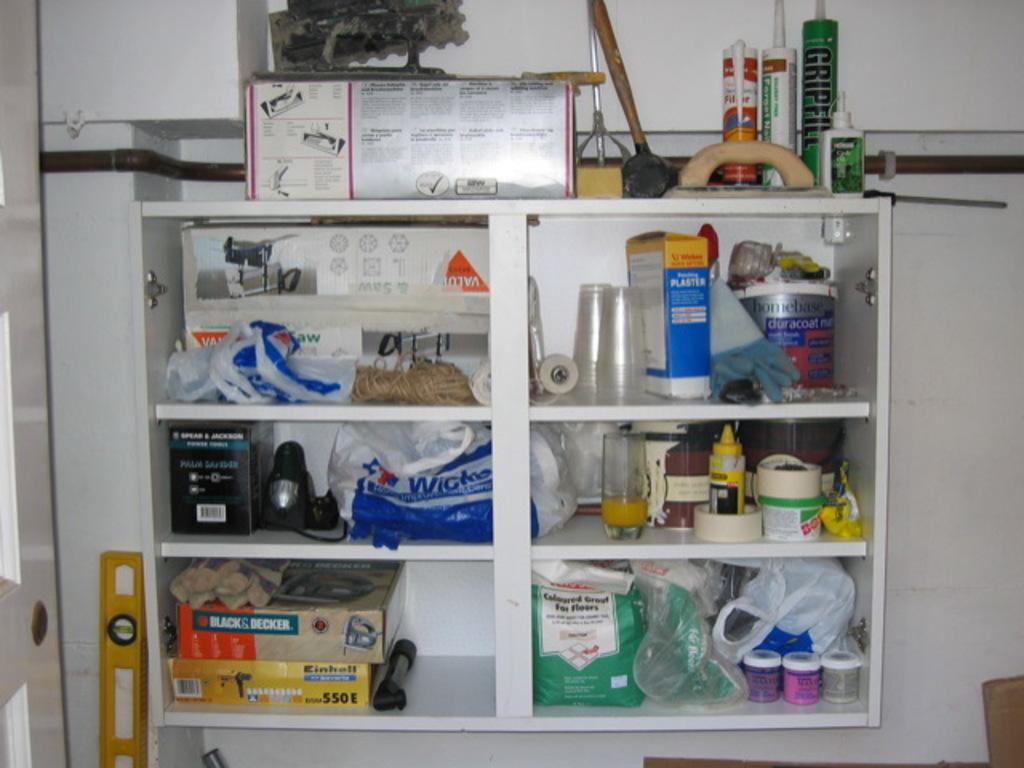What can be seen in the background of the image? There is a wall in the background of the image. What is present in the image besides the wall? There is a shelf in the image. What is on the shelf? There are objects on the shelf. What type of beast can be seen roaming around the shelf in the image? There is no beast present in the image; it only features a wall, a shelf, and objects on the shelf. What line can be seen connecting the objects on the shelf in the image? There is no line connecting the objects on the shelf in the image. 